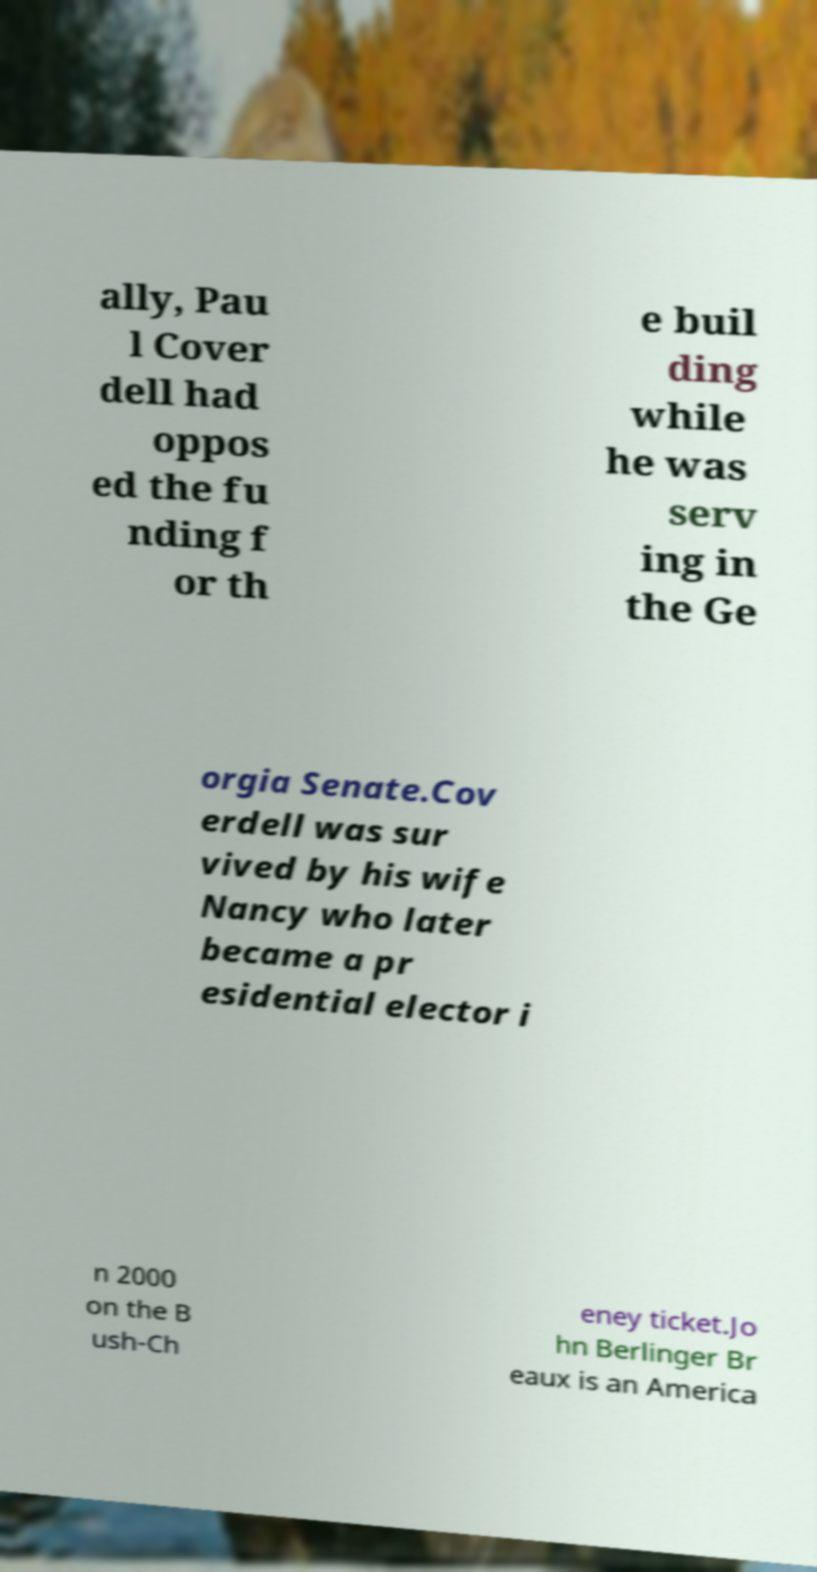For documentation purposes, I need the text within this image transcribed. Could you provide that? ally, Pau l Cover dell had oppos ed the fu nding f or th e buil ding while he was serv ing in the Ge orgia Senate.Cov erdell was sur vived by his wife Nancy who later became a pr esidential elector i n 2000 on the B ush-Ch eney ticket.Jo hn Berlinger Br eaux is an America 